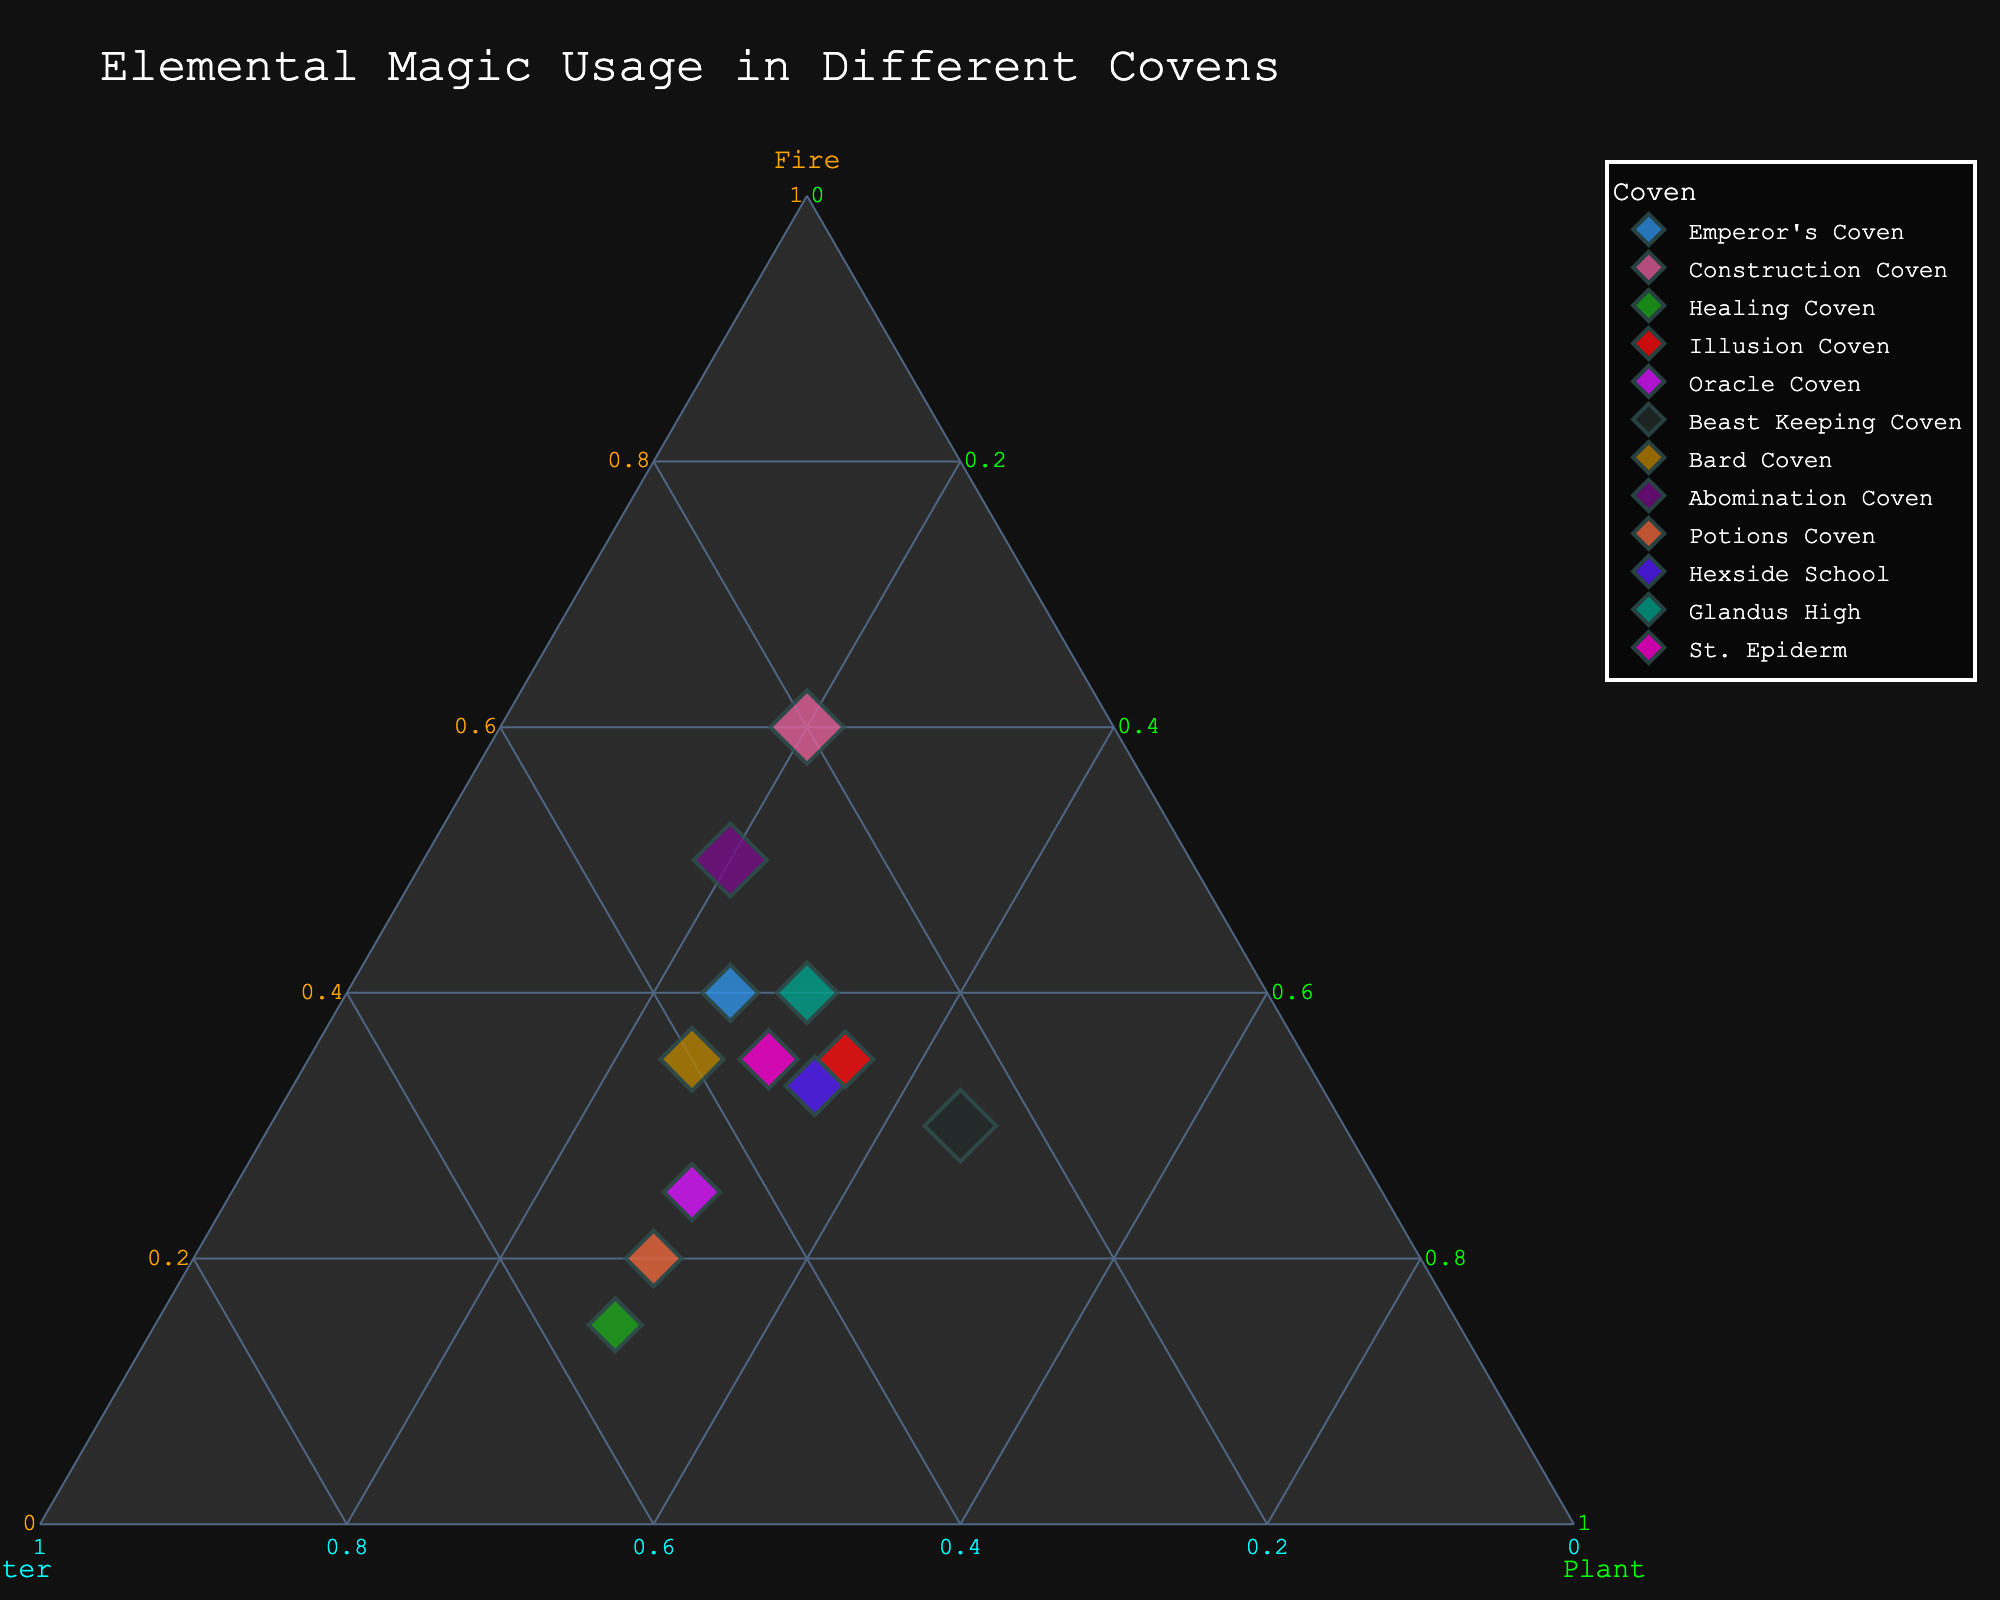What's the title of the plot? The title is usually displayed at the top of the plot. This plot has a title to indicate what it's about.
Answer: Elemental Magic Usage in Different Covens Which coven uses the most fire elemental magic? To determine which coven uses the most fire elemental magic, look at the axis labeled "Fire" and find the coven closest to the maximum value on that axis.
Answer: Construction Coven What are the fire, water, and plant percentages for Hexside School? By finding Hexside School on the ternary plot, you can read the values for fire, water, and plant elemental magic directly from the plot.
Answer: Fire: 33, Water: 33, Plant: 34 Which coven has equal distribution of fire and water elemental magic? Equal distribution of fire and water would mean the coven's point lies along the line between the fire and water axes at equal values. You can visually determine this from the plot.
Answer: St. Epiderm How many covens have water usage greater than 40? To find this, count the number of data points that lie closer to the "Water" vertex with values greater than 40.
Answer: 3 What is the sum of the elemental magic percentages (fire, water, and plant) for the Bard Coven? The sum of the percentages should always be 100% since they represent the entire distribution of elemental magic for each coven. Summing values directly confirms this.
Answer: 100 Which coven is closest to having an equal distribution of all three elements (fire, water, and plant)? An equal distribution means fire, water, and plant values are close to 33%. Identify the point closest to this balanced position.
Answer: Hexside School Compare the fire usage between the Emperor's Coven and the Abomination Coven; which is higher? Find the fire values for both covens on the plot and compare them directly.
Answer: Abomination Coven Which coven has the highest plant magic usage? To determine the coven with the highest plant usage, look for the point closest to the "Plant" vertex at a high value.
Answer: Beast Keeping Coven Calculate the average water usage for the covens with fire usage below 35%. Identify covens with fire usage below 35%, then average their water percentages: Healing Coven (55), Oracle Coven (45), Potions Coven (50). The average water usage is calculated as (55 + 45 + 50)/3.
Answer: 50 